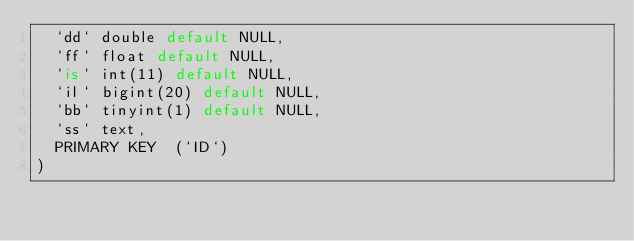<code> <loc_0><loc_0><loc_500><loc_500><_SQL_>  `dd` double default NULL,
  `ff` float default NULL,
  `is` int(11) default NULL,
  `il` bigint(20) default NULL,
  `bb` tinyint(1) default NULL,
  `ss` text,
  PRIMARY KEY  (`ID`)
)</code> 